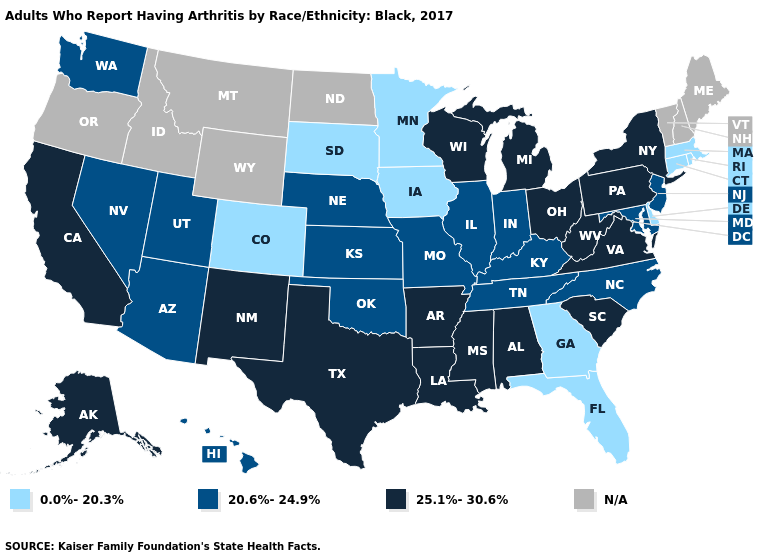Is the legend a continuous bar?
Be succinct. No. Does New Jersey have the highest value in the Northeast?
Give a very brief answer. No. Does the first symbol in the legend represent the smallest category?
Give a very brief answer. Yes. What is the highest value in the South ?
Keep it brief. 25.1%-30.6%. Name the states that have a value in the range 25.1%-30.6%?
Short answer required. Alabama, Alaska, Arkansas, California, Louisiana, Michigan, Mississippi, New Mexico, New York, Ohio, Pennsylvania, South Carolina, Texas, Virginia, West Virginia, Wisconsin. What is the highest value in the USA?
Keep it brief. 25.1%-30.6%. What is the value of Michigan?
Concise answer only. 25.1%-30.6%. What is the value of Wyoming?
Short answer required. N/A. Among the states that border Ohio , does Michigan have the lowest value?
Keep it brief. No. Among the states that border New Jersey , which have the lowest value?
Write a very short answer. Delaware. How many symbols are there in the legend?
Keep it brief. 4. What is the value of Hawaii?
Give a very brief answer. 20.6%-24.9%. Does the map have missing data?
Be succinct. Yes. 